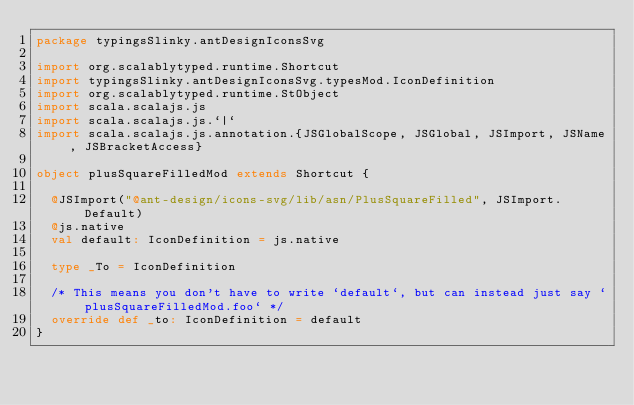<code> <loc_0><loc_0><loc_500><loc_500><_Scala_>package typingsSlinky.antDesignIconsSvg

import org.scalablytyped.runtime.Shortcut
import typingsSlinky.antDesignIconsSvg.typesMod.IconDefinition
import org.scalablytyped.runtime.StObject
import scala.scalajs.js
import scala.scalajs.js.`|`
import scala.scalajs.js.annotation.{JSGlobalScope, JSGlobal, JSImport, JSName, JSBracketAccess}

object plusSquareFilledMod extends Shortcut {
  
  @JSImport("@ant-design/icons-svg/lib/asn/PlusSquareFilled", JSImport.Default)
  @js.native
  val default: IconDefinition = js.native
  
  type _To = IconDefinition
  
  /* This means you don't have to write `default`, but can instead just say `plusSquareFilledMod.foo` */
  override def _to: IconDefinition = default
}
</code> 